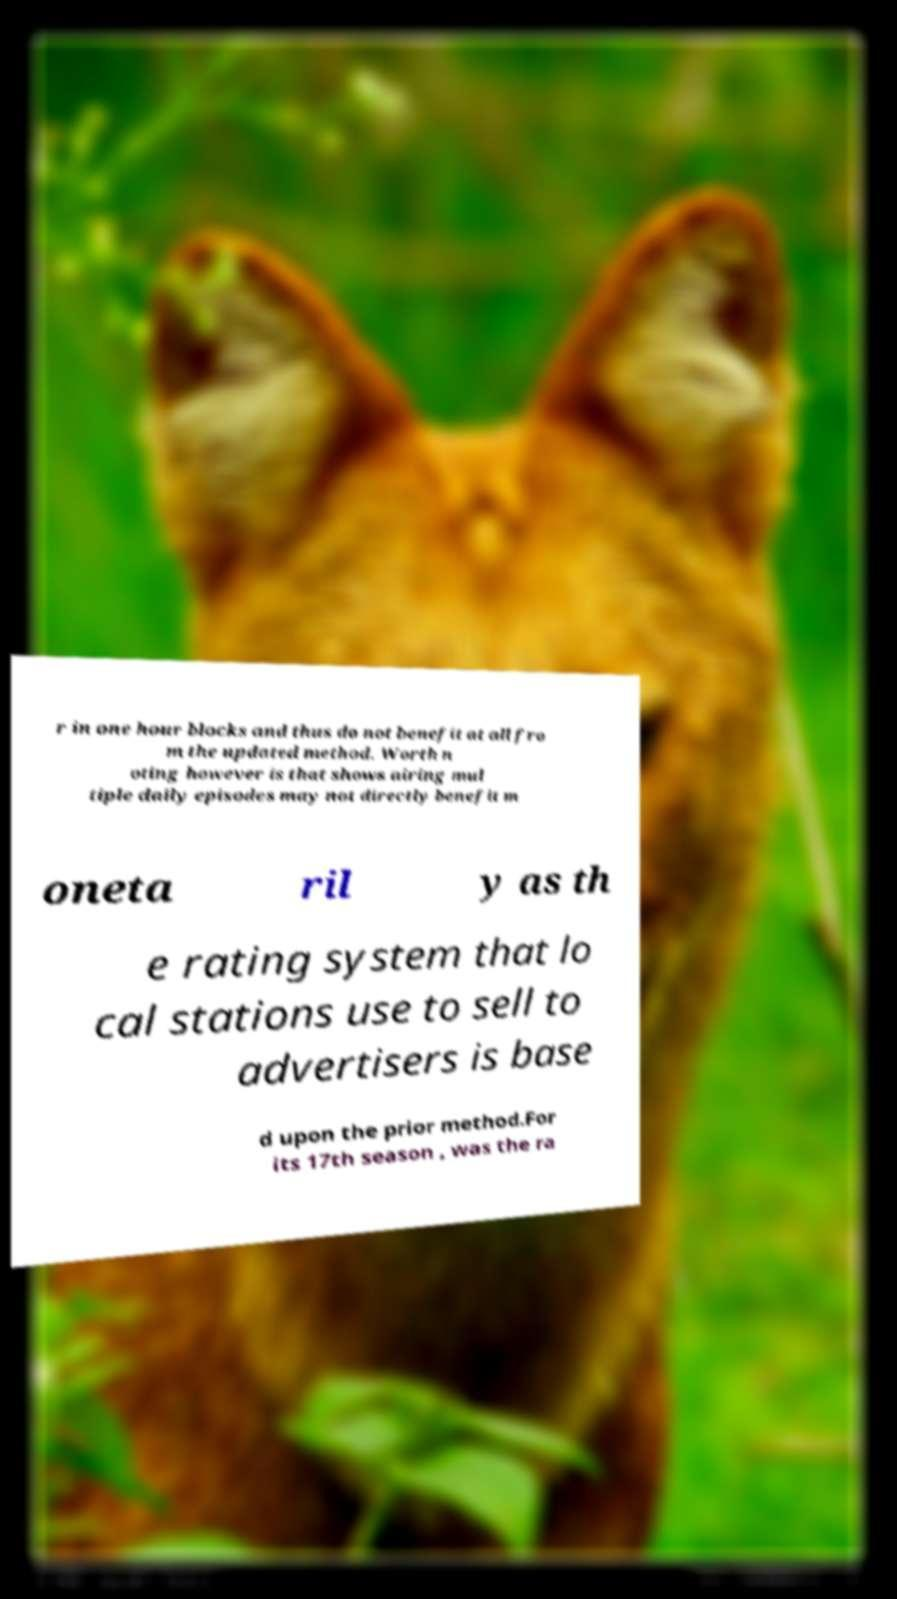Could you extract and type out the text from this image? r in one hour blocks and thus do not benefit at all fro m the updated method. Worth n oting however is that shows airing mul tiple daily episodes may not directly benefit m oneta ril y as th e rating system that lo cal stations use to sell to advertisers is base d upon the prior method.For its 17th season , was the ra 